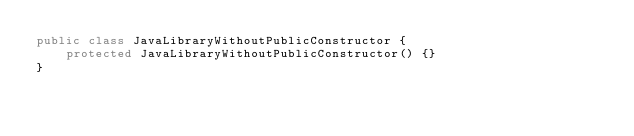Convert code to text. <code><loc_0><loc_0><loc_500><loc_500><_Java_>public class JavaLibraryWithoutPublicConstructor {
    protected JavaLibraryWithoutPublicConstructor() {}
}
</code> 